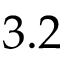Convert formula to latex. <formula><loc_0><loc_0><loc_500><loc_500>3 . 2</formula> 